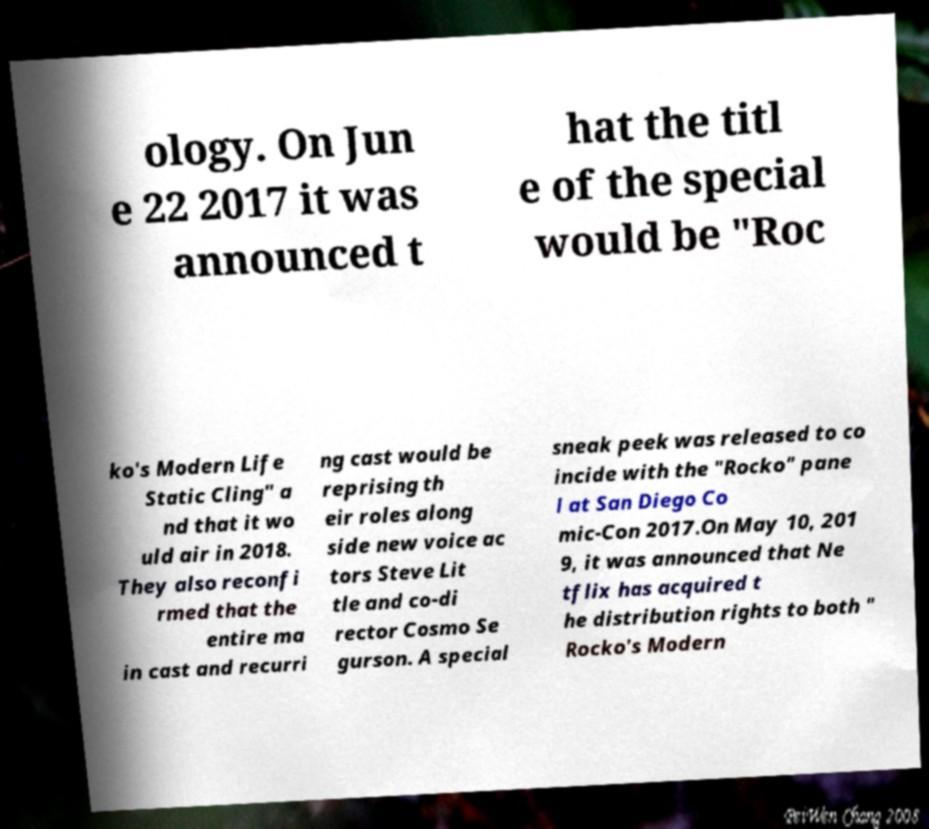There's text embedded in this image that I need extracted. Can you transcribe it verbatim? ology. On Jun e 22 2017 it was announced t hat the titl e of the special would be "Roc ko's Modern Life Static Cling" a nd that it wo uld air in 2018. They also reconfi rmed that the entire ma in cast and recurri ng cast would be reprising th eir roles along side new voice ac tors Steve Lit tle and co-di rector Cosmo Se gurson. A special sneak peek was released to co incide with the "Rocko" pane l at San Diego Co mic-Con 2017.On May 10, 201 9, it was announced that Ne tflix has acquired t he distribution rights to both " Rocko's Modern 